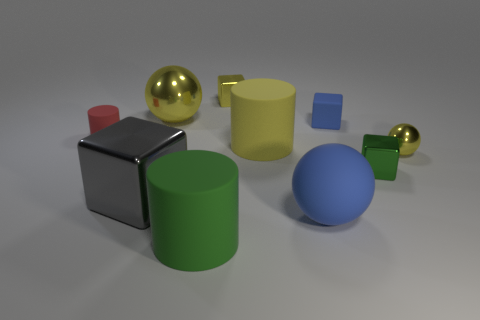How many things are yellow things that are to the left of the rubber sphere or yellow balls?
Keep it short and to the point. 4. Are there more blue rubber objects that are on the right side of the tiny blue block than metal spheres in front of the red cylinder?
Ensure brevity in your answer.  No. Is the material of the red thing the same as the small yellow cube?
Your answer should be very brief. No. There is a rubber thing that is behind the big gray block and in front of the tiny red cylinder; what shape is it?
Offer a terse response. Cylinder. The yellow thing that is the same material as the large blue sphere is what shape?
Provide a short and direct response. Cylinder. Are any tiny things visible?
Offer a very short reply. Yes. Is there a large yellow shiny sphere that is behind the tiny yellow thing in front of the large yellow cylinder?
Ensure brevity in your answer.  Yes. There is a small thing that is the same shape as the large green rubber object; what is it made of?
Offer a very short reply. Rubber. Is the number of large purple metal things greater than the number of tiny green metal blocks?
Your answer should be very brief. No. There is a rubber ball; does it have the same color as the cube that is on the left side of the small yellow cube?
Make the answer very short. No. 